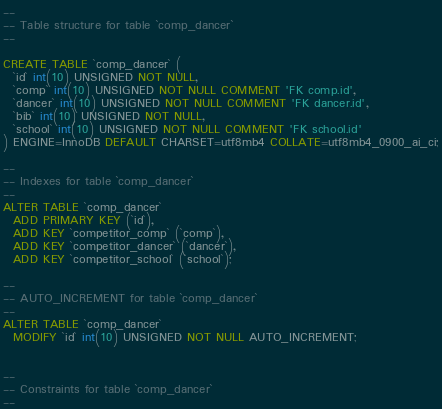<code> <loc_0><loc_0><loc_500><loc_500><_SQL_>--
-- Table structure for table `comp_dancer`
--

CREATE TABLE `comp_dancer` (
  `id` int(10) UNSIGNED NOT NULL,
  `comp` int(10) UNSIGNED NOT NULL COMMENT 'FK comp.id',
  `dancer` int(10) UNSIGNED NOT NULL COMMENT 'FK dancer.id',
  `bib` int(10) UNSIGNED NOT NULL,
  `school` int(10) UNSIGNED NOT NULL COMMENT 'FK school.id'
) ENGINE=InnoDB DEFAULT CHARSET=utf8mb4 COLLATE=utf8mb4_0900_ai_ci;

--
-- Indexes for table `comp_dancer`
--
ALTER TABLE `comp_dancer`
  ADD PRIMARY KEY (`id`),
  ADD KEY `competitor_comp` (`comp`),
  ADD KEY `competitor_dancer` (`dancer`),
  ADD KEY `competitor_school` (`school`);

--
-- AUTO_INCREMENT for table `comp_dancer`
--
ALTER TABLE `comp_dancer`
  MODIFY `id` int(10) UNSIGNED NOT NULL AUTO_INCREMENT;


--
-- Constraints for table `comp_dancer`
--</code> 